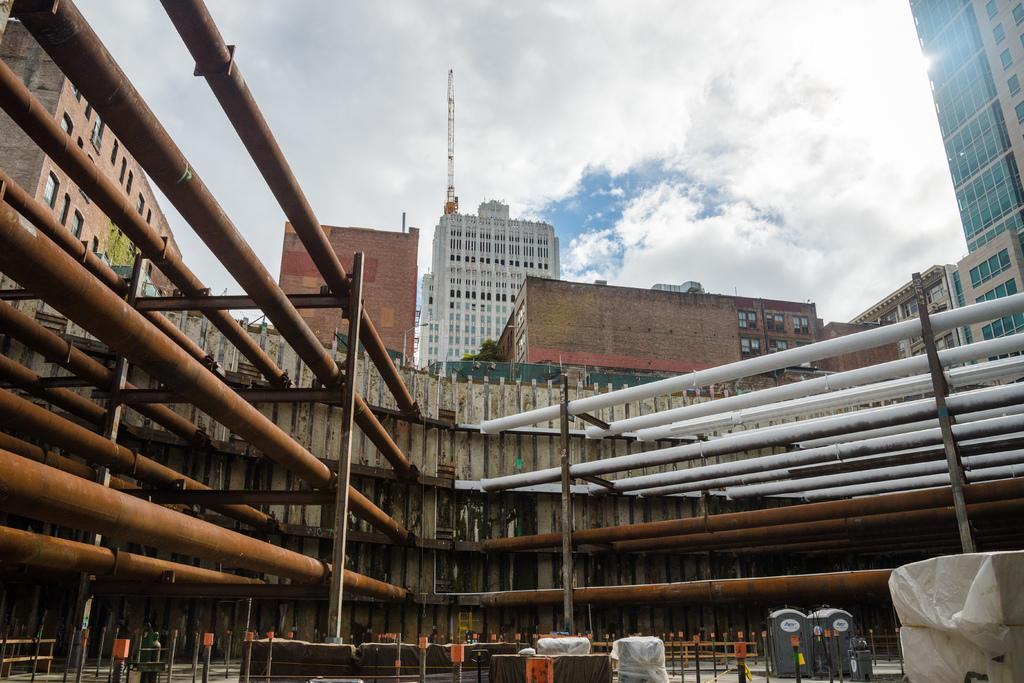What type of structures are present in the image? There are buildings in the image. What is attached to the buildings in the image? There are rods attached to the buildings. What can be seen at the bottom of the image? There are objects at the bottom of the image. What is visible in the background of the image? The sky is visible in the background of the image. What type of suit is the stem wearing in the image? There is no suit or stem present in the image. 